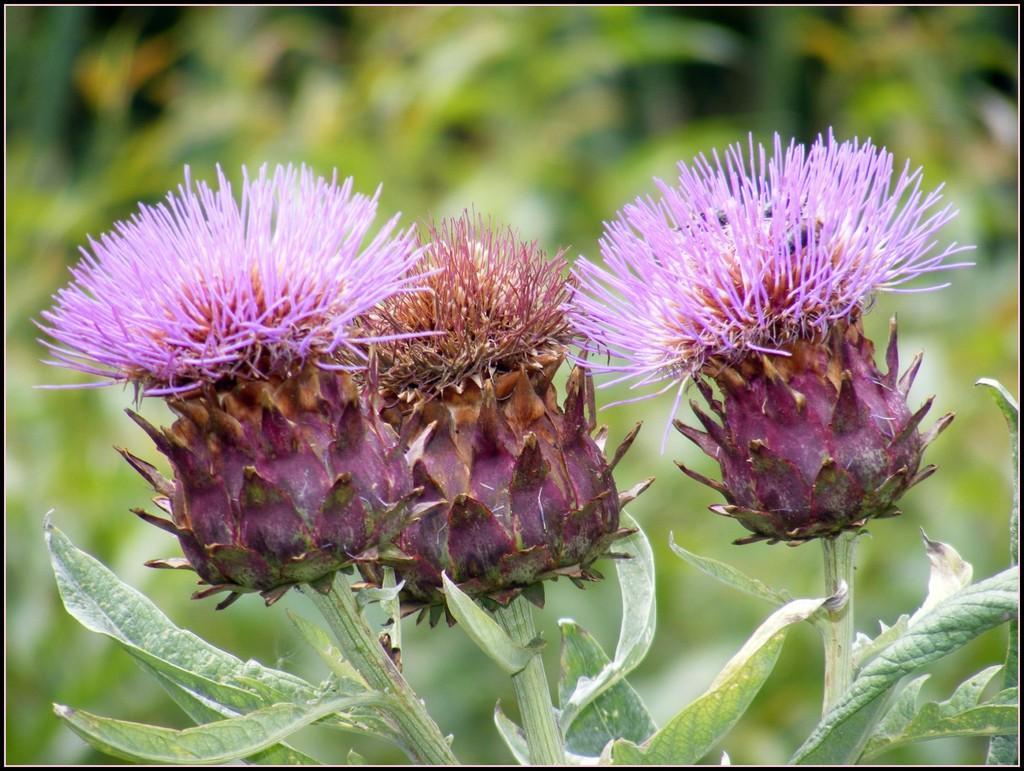Can you describe this image briefly? Here I can see few plants along with the flowers and leaves. The background is blurred. 